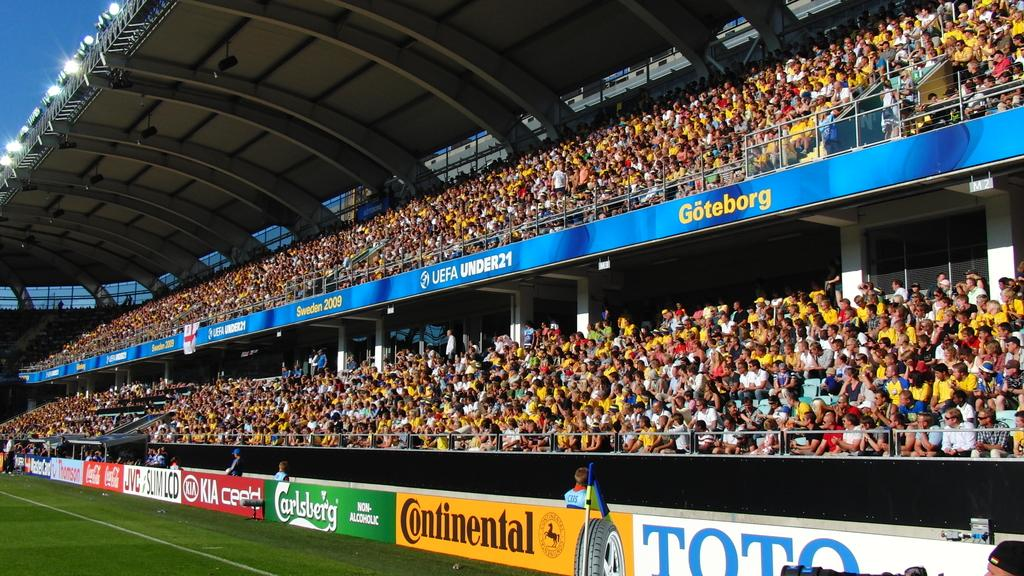<image>
Present a compact description of the photo's key features. A bright yellow Continental sign is among other signs around the edge of a stadium. 